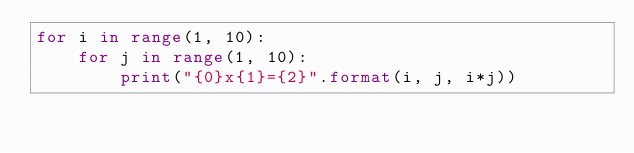Convert code to text. <code><loc_0><loc_0><loc_500><loc_500><_Python_>for i in range(1, 10):
    for j in range(1, 10):
        print("{0}x{1}={2}".format(i, j, i*j))</code> 